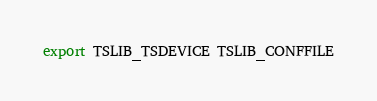Convert code to text. <code><loc_0><loc_0><loc_500><loc_500><_Bash_>
export TSLIB_TSDEVICE TSLIB_CONFFILE

</code> 